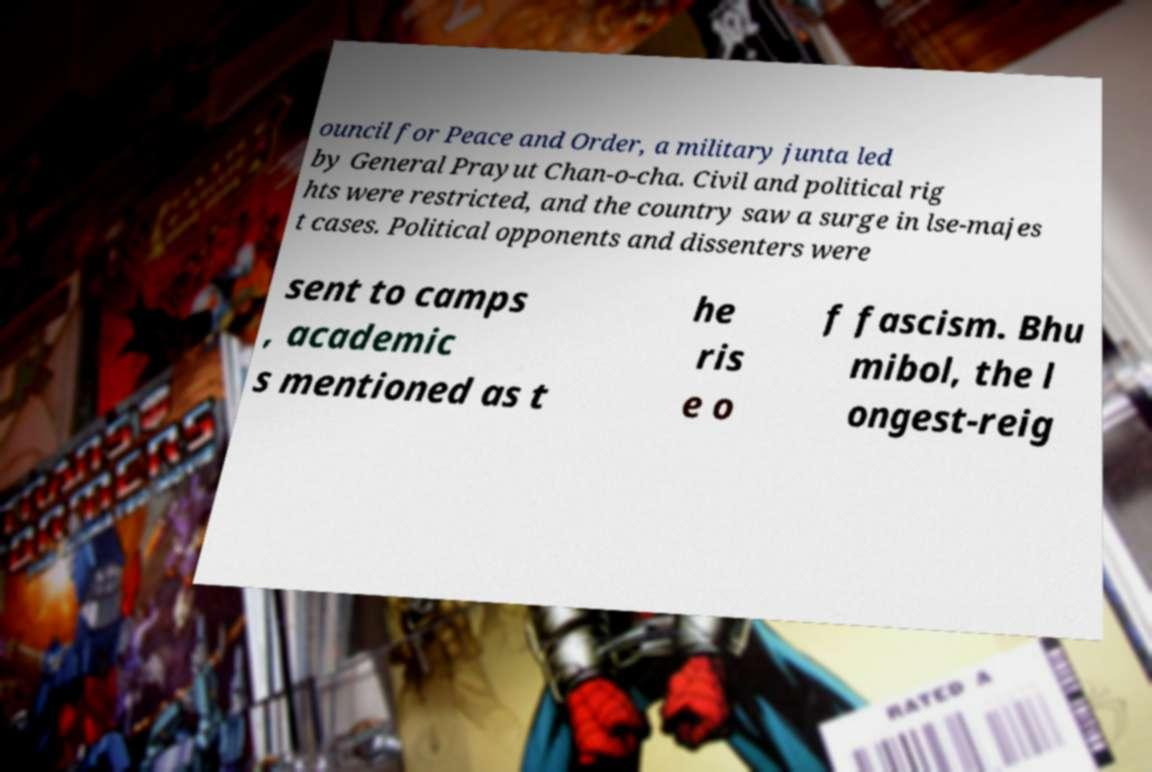Can you accurately transcribe the text from the provided image for me? ouncil for Peace and Order, a military junta led by General Prayut Chan-o-cha. Civil and political rig hts were restricted, and the country saw a surge in lse-majes t cases. Political opponents and dissenters were sent to camps , academic s mentioned as t he ris e o f fascism. Bhu mibol, the l ongest-reig 